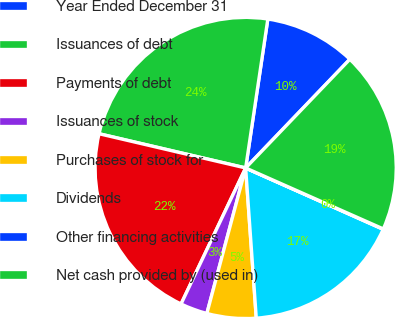<chart> <loc_0><loc_0><loc_500><loc_500><pie_chart><fcel>Year Ended December 31<fcel>Issuances of debt<fcel>Payments of debt<fcel>Issuances of stock<fcel>Purchases of stock for<fcel>Dividends<fcel>Other financing activities<fcel>Net cash provided by (used in)<nl><fcel>9.81%<fcel>23.7%<fcel>21.59%<fcel>2.91%<fcel>5.27%<fcel>17.2%<fcel>0.04%<fcel>19.47%<nl></chart> 